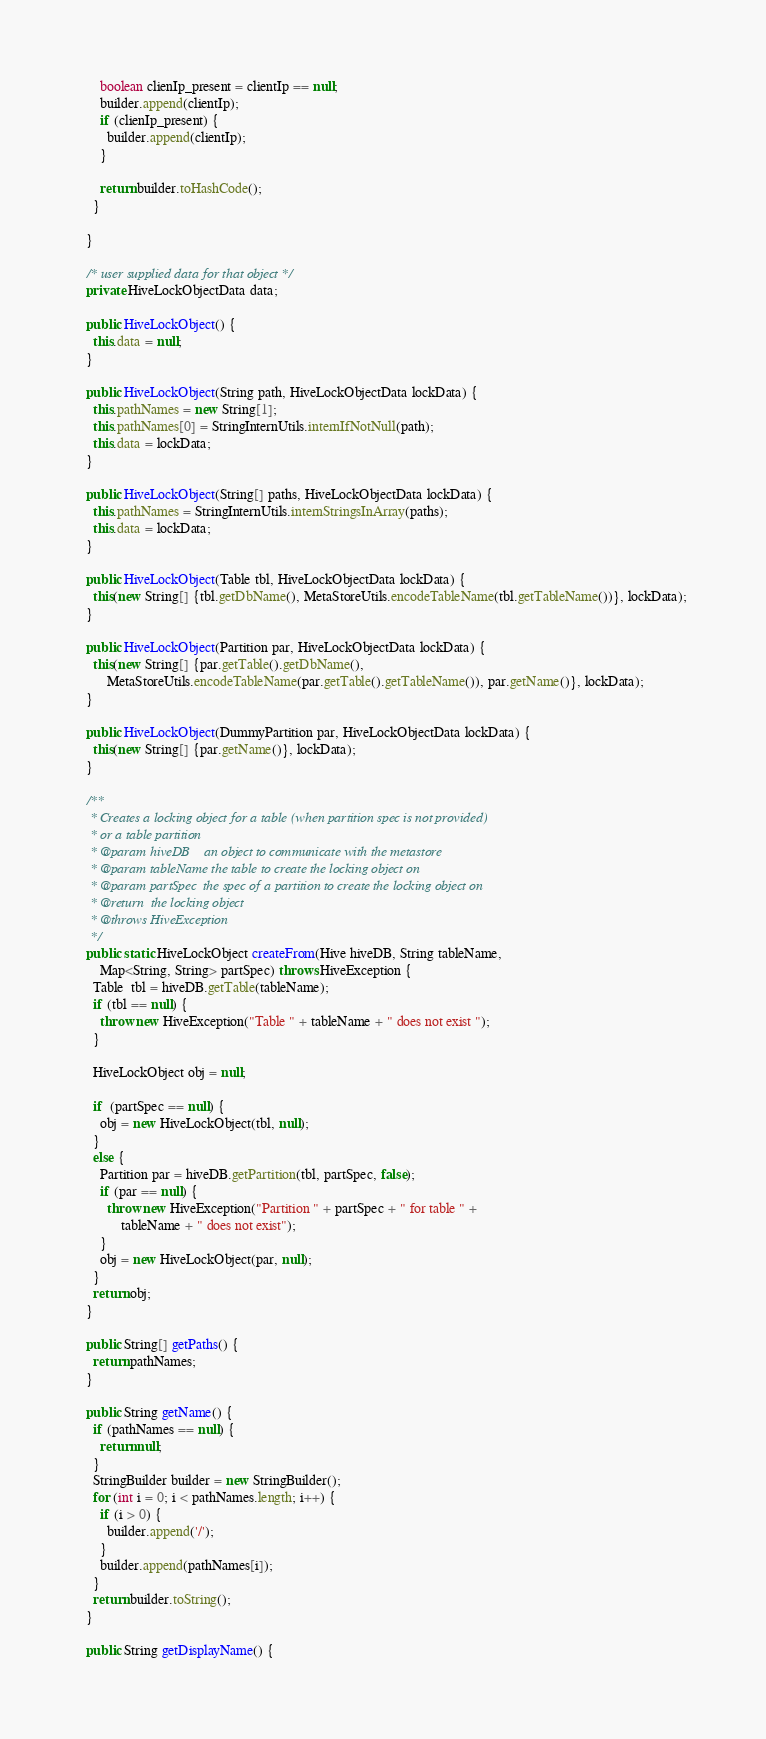<code> <loc_0><loc_0><loc_500><loc_500><_Java_>
      boolean clienIp_present = clientIp == null;
      builder.append(clientIp);
      if (clienIp_present) {
        builder.append(clientIp);
      }

      return builder.toHashCode();
    }

  }

  /* user supplied data for that object */
  private HiveLockObjectData data;

  public HiveLockObject() {
    this.data = null;
  }

  public HiveLockObject(String path, HiveLockObjectData lockData) {
    this.pathNames = new String[1];
    this.pathNames[0] = StringInternUtils.internIfNotNull(path);
    this.data = lockData;
  }

  public HiveLockObject(String[] paths, HiveLockObjectData lockData) {
    this.pathNames = StringInternUtils.internStringsInArray(paths);
    this.data = lockData;
  }

  public HiveLockObject(Table tbl, HiveLockObjectData lockData) {
    this(new String[] {tbl.getDbName(), MetaStoreUtils.encodeTableName(tbl.getTableName())}, lockData);
  }

  public HiveLockObject(Partition par, HiveLockObjectData lockData) {
    this(new String[] {par.getTable().getDbName(),
        MetaStoreUtils.encodeTableName(par.getTable().getTableName()), par.getName()}, lockData);
  }

  public HiveLockObject(DummyPartition par, HiveLockObjectData lockData) {
    this(new String[] {par.getName()}, lockData);
  }

  /**
   * Creates a locking object for a table (when partition spec is not provided)
   * or a table partition
   * @param hiveDB    an object to communicate with the metastore
   * @param tableName the table to create the locking object on
   * @param partSpec  the spec of a partition to create the locking object on
   * @return  the locking object
   * @throws HiveException
   */
  public static HiveLockObject createFrom(Hive hiveDB, String tableName,
      Map<String, String> partSpec) throws HiveException {
    Table  tbl = hiveDB.getTable(tableName);
    if (tbl == null) {
      throw new HiveException("Table " + tableName + " does not exist ");
    }

    HiveLockObject obj = null;

    if  (partSpec == null) {
      obj = new HiveLockObject(tbl, null);
    }
    else {
      Partition par = hiveDB.getPartition(tbl, partSpec, false);
      if (par == null) {
        throw new HiveException("Partition " + partSpec + " for table " +
            tableName + " does not exist");
      }
      obj = new HiveLockObject(par, null);
    }
    return obj;
  }

  public String[] getPaths() {
    return pathNames;
  }

  public String getName() {
    if (pathNames == null) {
      return null;
    }
    StringBuilder builder = new StringBuilder();
    for (int i = 0; i < pathNames.length; i++) {
      if (i > 0) {
        builder.append('/');
      }
      builder.append(pathNames[i]);
    }
    return builder.toString();
  }

  public String getDisplayName() {</code> 